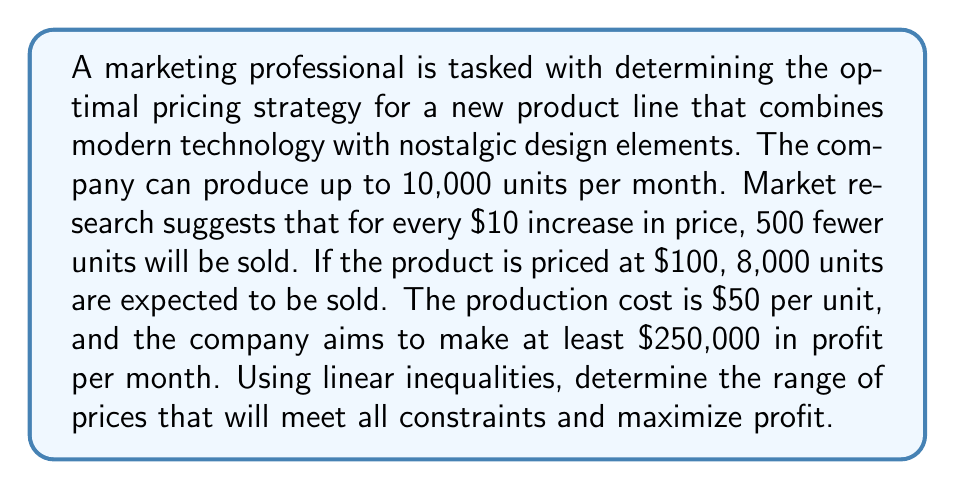Can you answer this question? Let's approach this step-by-step:

1) Let $x$ be the price of the product in dollars, and $y$ be the number of units sold.

2) From the given information, we can form the demand equation:
   $y = 13000 - 50x$

3) The production constraint is:
   $y \leq 10000$

4) The profit function is:
   $P = y(x - 50)$

5) The profit constraint is:
   $P \geq 250000$

6) Substituting the demand equation into the profit constraint:
   $(13000 - 50x)(x - 50) \geq 250000$

7) Expanding this inequality:
   $13000x - 650000 - 50x^2 + 2500x \geq 250000$
   $-50x^2 + 15500x - 900000 \geq 0$

8) Solving this quadratic inequality:
   $x \leq 180$ or $x \geq 130$

9) From the production constraint:
   $13000 - 50x \leq 10000$
   $x \geq 60$

10) Combining all constraints:
    $130 \leq x \leq 180$

11) To maximize profit, we should choose the highest price in this range, which is $180.
Answer: $130 \leq x \leq 180$, with $x = 180$ maximizing profit 